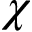Convert formula to latex. <formula><loc_0><loc_0><loc_500><loc_500>\chi</formula> 